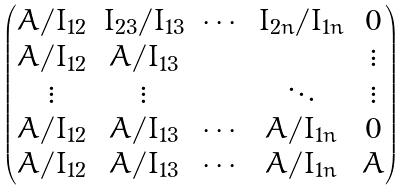<formula> <loc_0><loc_0><loc_500><loc_500>\begin{pmatrix} A / I _ { 1 2 } & I _ { 2 3 } / I _ { 1 3 } & \cdots & I _ { 2 n } / I _ { 1 n } & 0 \\ A / I _ { 1 2 } & A / I _ { 1 3 } & & & \vdots \\ \vdots & \vdots & & \ddots & \vdots \\ A / I _ { 1 2 } & A / I _ { 1 3 } & \cdots & A / I _ { 1 n } & 0 \\ A / I _ { 1 2 } & A / I _ { 1 3 } & \cdots & A / I _ { 1 n } & A \end{pmatrix}</formula> 